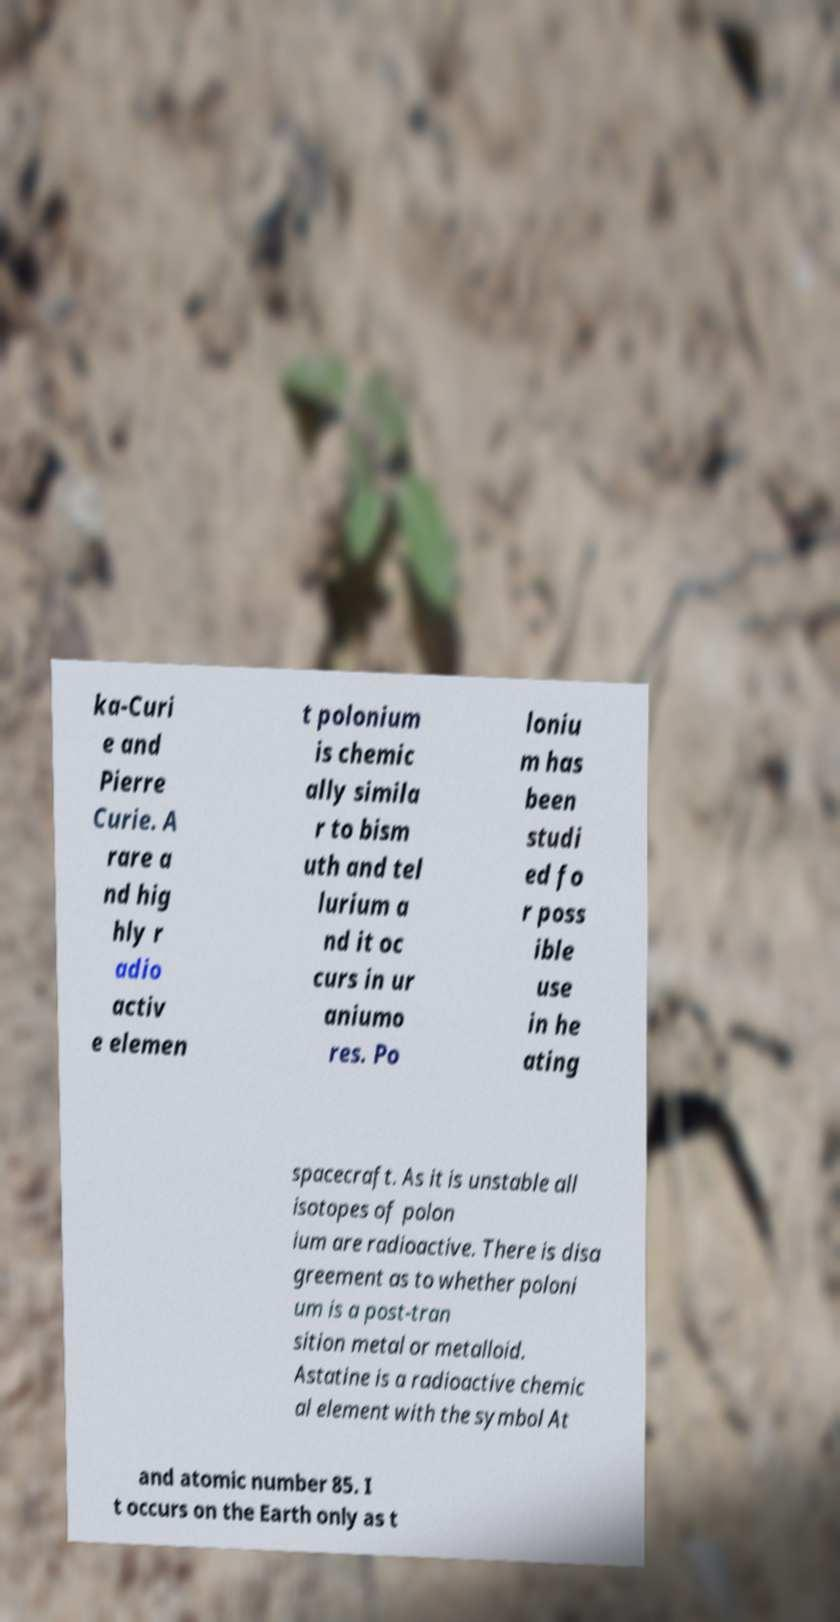I need the written content from this picture converted into text. Can you do that? ka-Curi e and Pierre Curie. A rare a nd hig hly r adio activ e elemen t polonium is chemic ally simila r to bism uth and tel lurium a nd it oc curs in ur aniumo res. Po loniu m has been studi ed fo r poss ible use in he ating spacecraft. As it is unstable all isotopes of polon ium are radioactive. There is disa greement as to whether poloni um is a post-tran sition metal or metalloid. Astatine is a radioactive chemic al element with the symbol At and atomic number 85. I t occurs on the Earth only as t 